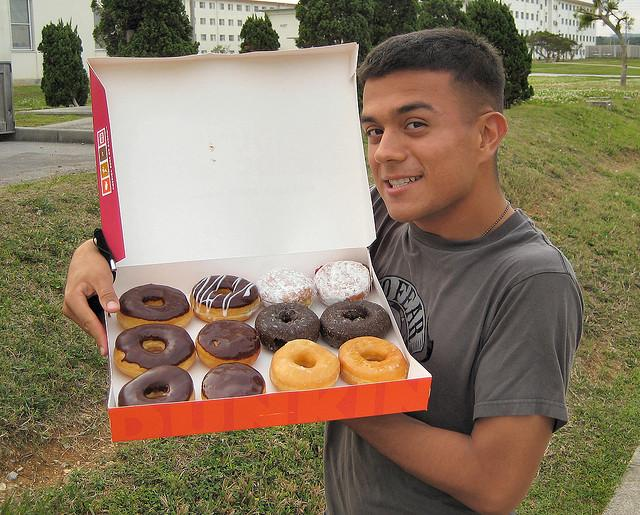What morning beverage is this company famous for?

Choices:
A) oatmeal
B) lemonade
C) coffee
D) fruit punch coffee 